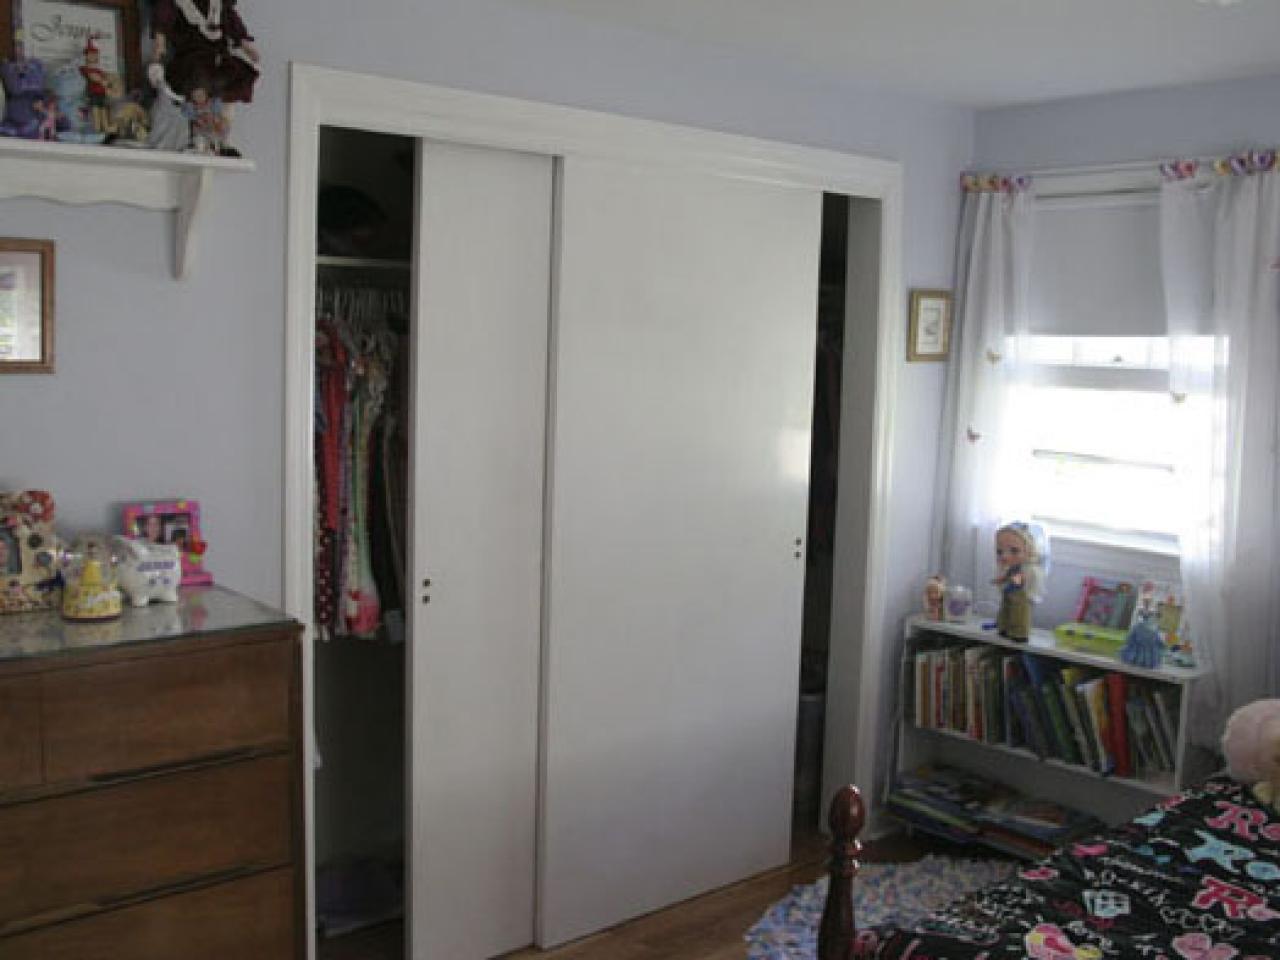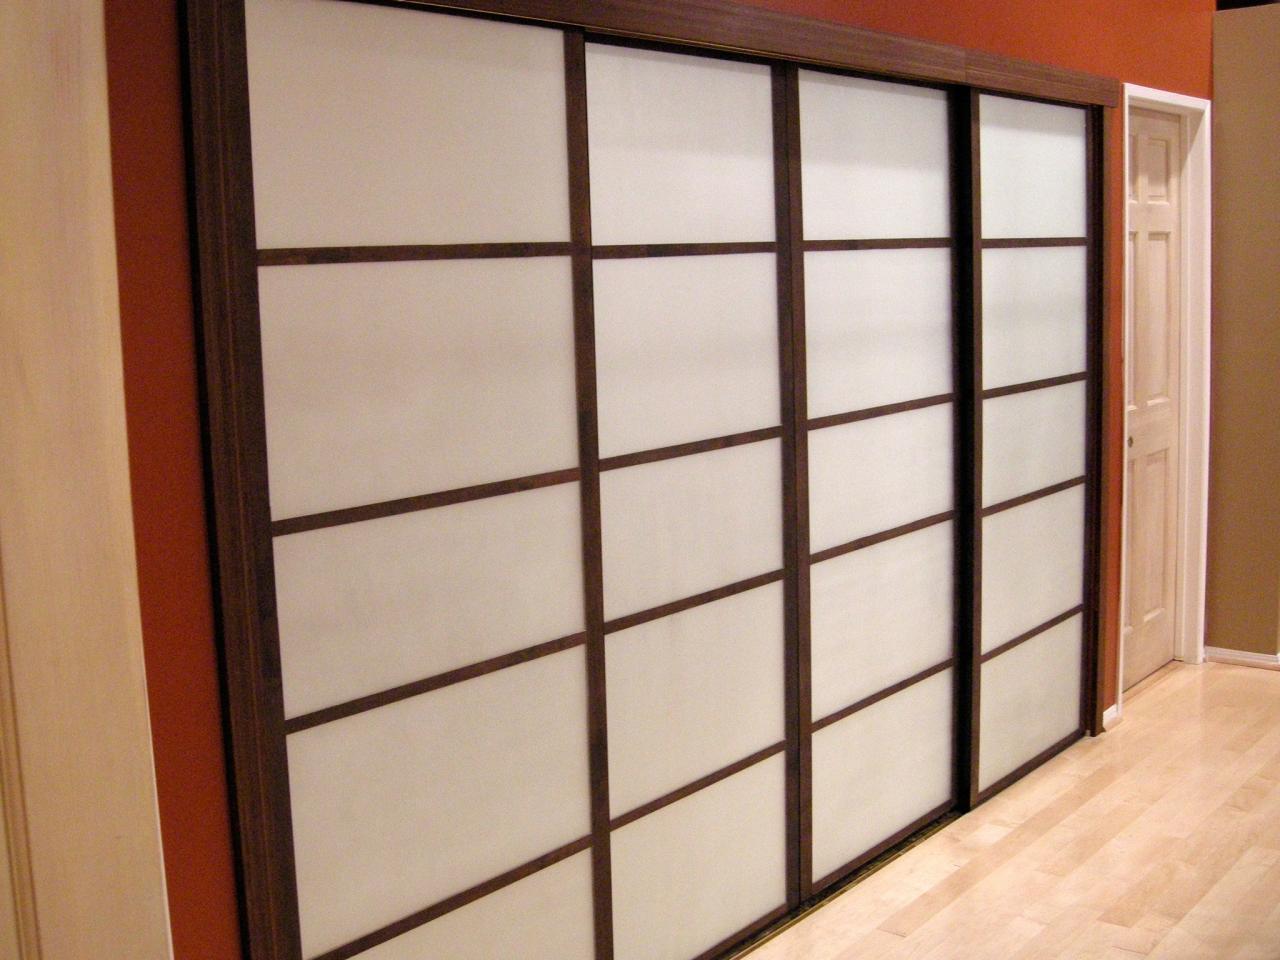The first image is the image on the left, the second image is the image on the right. For the images displayed, is the sentence "An image shows triple wooden sliding doors topped with molding trim." factually correct? Answer yes or no. No. The first image is the image on the left, the second image is the image on the right. Evaluate the accuracy of this statement regarding the images: "Two sets of closed closet doors have the same number of panels, but one set is wider than the other.". Is it true? Answer yes or no. No. The first image is the image on the left, the second image is the image on the right. Considering the images on both sides, is "In one image, a tan wood three-panel door has square inlays at the top and two long rectangles at the bottom." valid? Answer yes or no. No. 